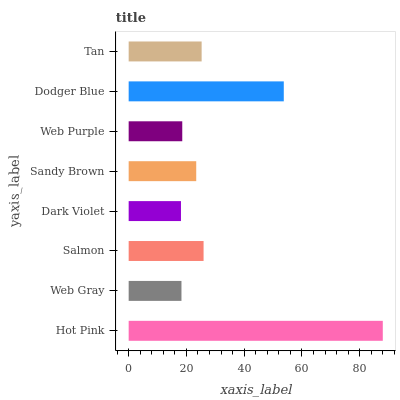Is Dark Violet the minimum?
Answer yes or no. Yes. Is Hot Pink the maximum?
Answer yes or no. Yes. Is Web Gray the minimum?
Answer yes or no. No. Is Web Gray the maximum?
Answer yes or no. No. Is Hot Pink greater than Web Gray?
Answer yes or no. Yes. Is Web Gray less than Hot Pink?
Answer yes or no. Yes. Is Web Gray greater than Hot Pink?
Answer yes or no. No. Is Hot Pink less than Web Gray?
Answer yes or no. No. Is Tan the high median?
Answer yes or no. Yes. Is Sandy Brown the low median?
Answer yes or no. Yes. Is Dodger Blue the high median?
Answer yes or no. No. Is Dodger Blue the low median?
Answer yes or no. No. 